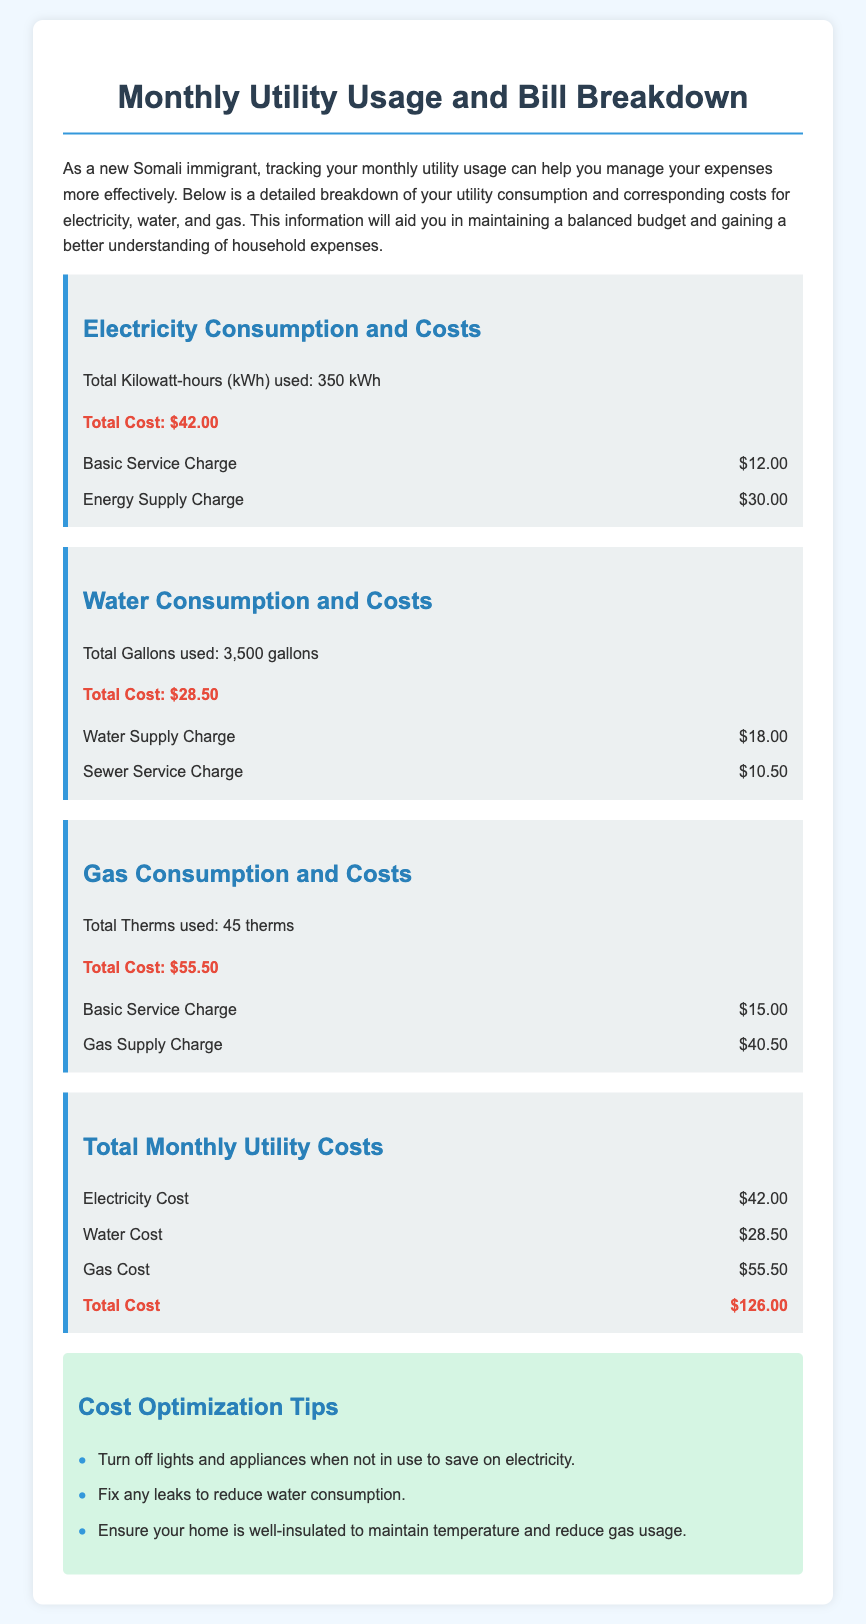what is the total kilowatt-hours used for electricity? The total kilowatt-hours used for electricity is explicitly stated in the document, which is 350 kWh.
Answer: 350 kWh what is the total cost for water? The total cost for water can be found in the water consumption section, which is $28.50.
Answer: $28.50 how many gallons of water were used? The document specifies the total gallons used for water consumption, which is 3,500 gallons.
Answer: 3,500 gallons what is the basic service charge for gas? The basic service charge for gas is mentioned in the gas consumption section, which is $15.00.
Answer: $15.00 what is the total cost of utilities? The total cost of utilities is the sum of the electricity, water, and gas costs in the document, which totals $126.00.
Answer: $126.00 which utility has the highest monthly cost? By comparing the costs of electricity, water, and gas in the document, it is clear that gas has the highest monthly cost at $55.50.
Answer: Gas how much is the energy supply charge for electricity? The energy supply charge for electricity appears in the cost breakdown, which is $30.00.
Answer: $30.00 how many therms of gas were used? The document indicates the total therms used for gas consumption, which is 45 therms.
Answer: 45 therms what does the document suggest to reduce electricity costs? The document lists tips for optimizing costs, one of which is to turn off lights and appliances when not in use.
Answer: Turn off lights and appliances when not in use 